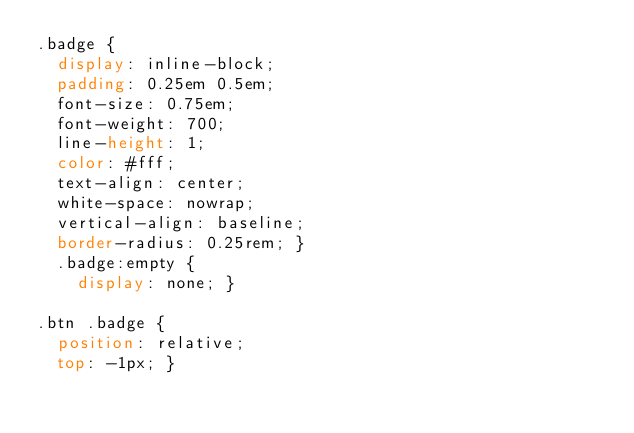Convert code to text. <code><loc_0><loc_0><loc_500><loc_500><_CSS_>.badge {
  display: inline-block;
  padding: 0.25em 0.5em;
  font-size: 0.75em;
  font-weight: 700;
  line-height: 1;
  color: #fff;
  text-align: center;
  white-space: nowrap;
  vertical-align: baseline;
  border-radius: 0.25rem; }
  .badge:empty {
    display: none; }

.btn .badge {
  position: relative;
  top: -1px; }
</code> 